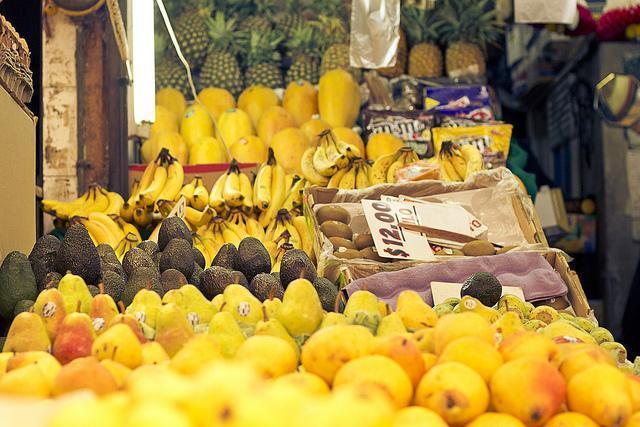How many bananas are in the photo?
Give a very brief answer. 2. 